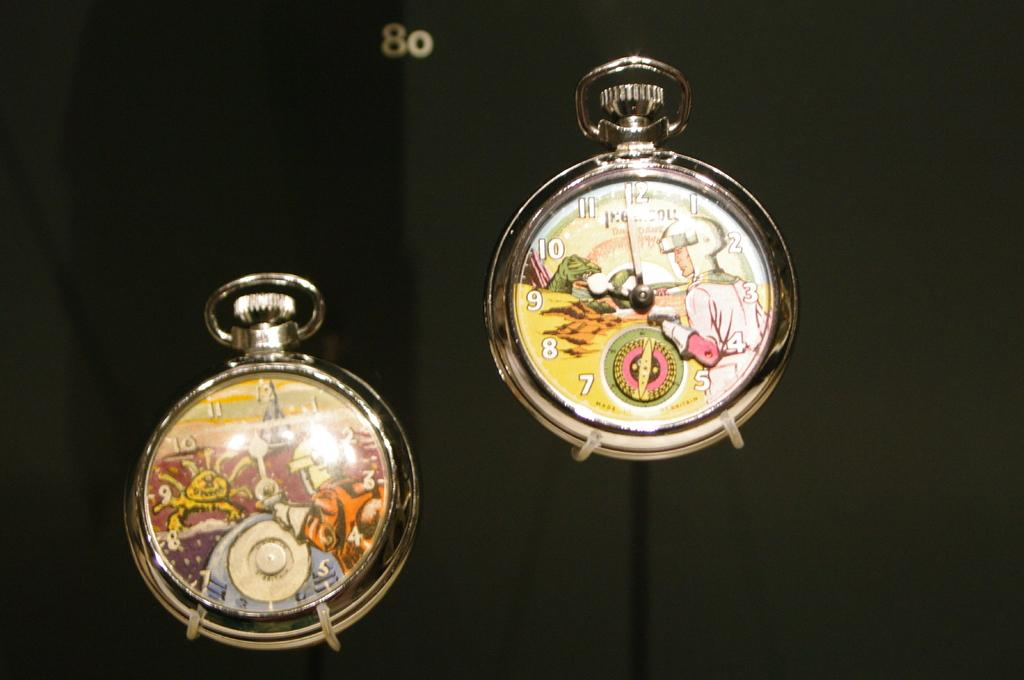<image>
Create a compact narrative representing the image presented. Artistically painted pocket watches, the one on the right shows it to be three o clock. 